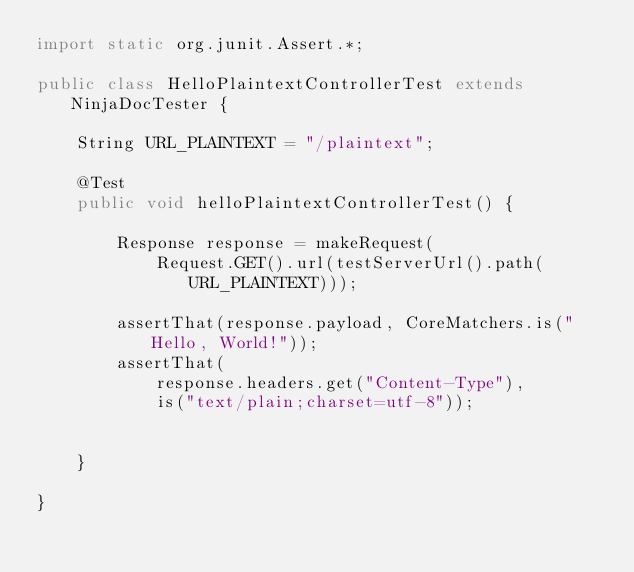<code> <loc_0><loc_0><loc_500><loc_500><_Java_>import static org.junit.Assert.*;

public class HelloPlaintextControllerTest extends NinjaDocTester {
    
    String URL_PLAINTEXT = "/plaintext";
    
    @Test
    public void helloPlaintextControllerTest() {
        
        Response response = makeRequest(
            Request.GET().url(testServerUrl().path(URL_PLAINTEXT)));
        
        assertThat(response.payload, CoreMatchers.is("Hello, World!"));
        assertThat(
            response.headers.get("Content-Type"), 
            is("text/plain;charset=utf-8"));
        
   
    }
    
}
</code> 